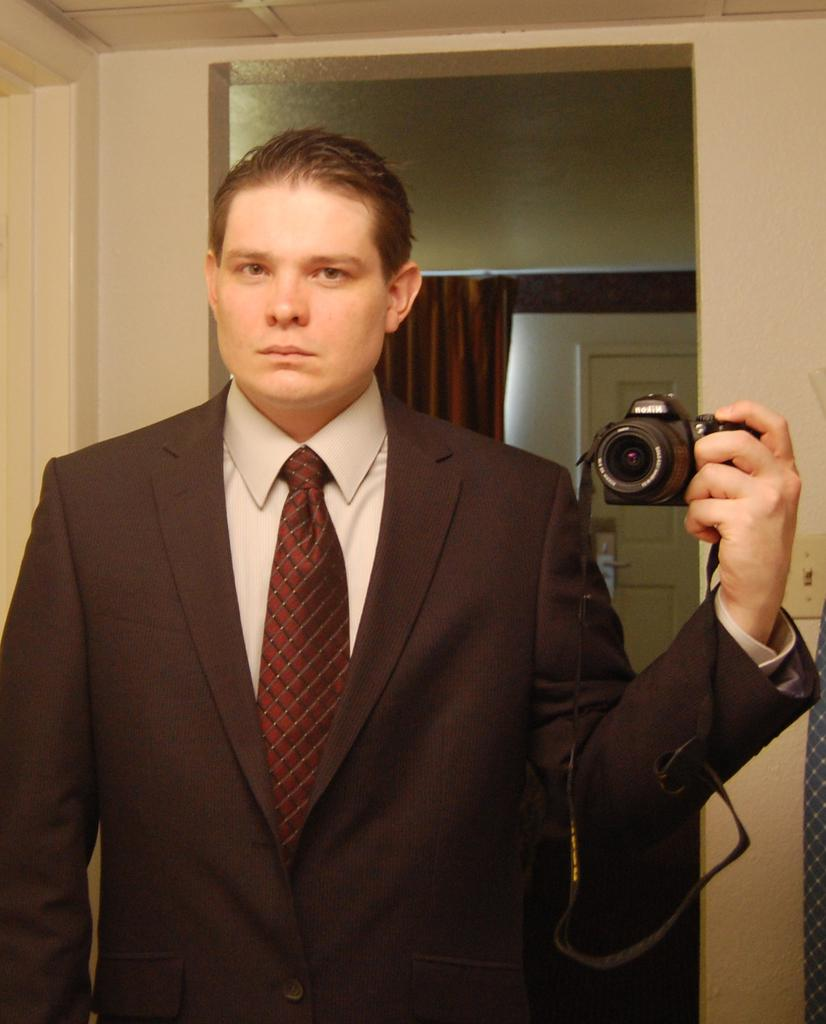Who is the main subject in the image? There is a man in the center of the image. What is the man wearing? The man is wearing a suit. What is the man holding in his hand? The man is holding a camera in his hand. What can be seen in the background of the image? There is a wall and a curtain in the background of the image. What type of steel is used to construct the curtain in the image? There is no steel used in the construction of the curtain in the image; it is made of fabric. 